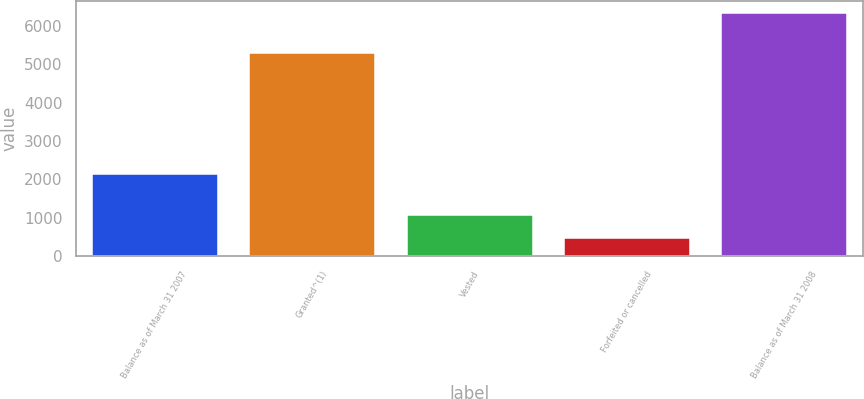Convert chart. <chart><loc_0><loc_0><loc_500><loc_500><bar_chart><fcel>Balance as of March 31 2007<fcel>Granted^(1)<fcel>Vested<fcel>Forfeited or cancelled<fcel>Balance as of March 31 2008<nl><fcel>2134<fcel>5293<fcel>1071.8<fcel>486<fcel>6344<nl></chart> 